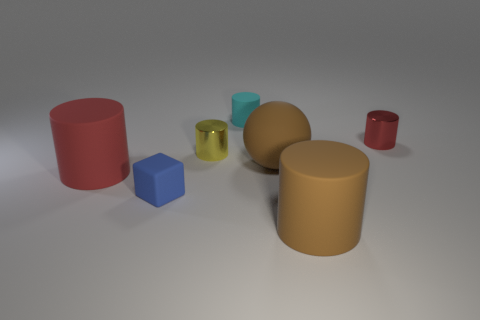There is a blue thing that is made of the same material as the small cyan cylinder; what size is it?
Make the answer very short. Small. Does the tiny cyan object have the same shape as the tiny yellow thing?
Your answer should be compact. Yes. What color is the matte ball that is the same size as the brown cylinder?
Your answer should be very brief. Brown. What is the size of the cyan matte thing that is the same shape as the big red object?
Ensure brevity in your answer.  Small. The object to the right of the brown matte cylinder has what shape?
Your answer should be compact. Cylinder. Does the cyan object have the same shape as the brown rubber object that is behind the red rubber cylinder?
Give a very brief answer. No. Are there the same number of matte cylinders that are left of the large brown cylinder and big brown cylinders right of the red metallic cylinder?
Ensure brevity in your answer.  No. The thing that is the same color as the matte ball is what shape?
Keep it short and to the point. Cylinder. There is a tiny metallic cylinder that is right of the big brown matte cylinder; is its color the same as the big thing left of the yellow metal cylinder?
Give a very brief answer. Yes. Is the number of tiny rubber objects left of the large brown rubber cylinder greater than the number of tiny metallic things?
Offer a very short reply. No. 